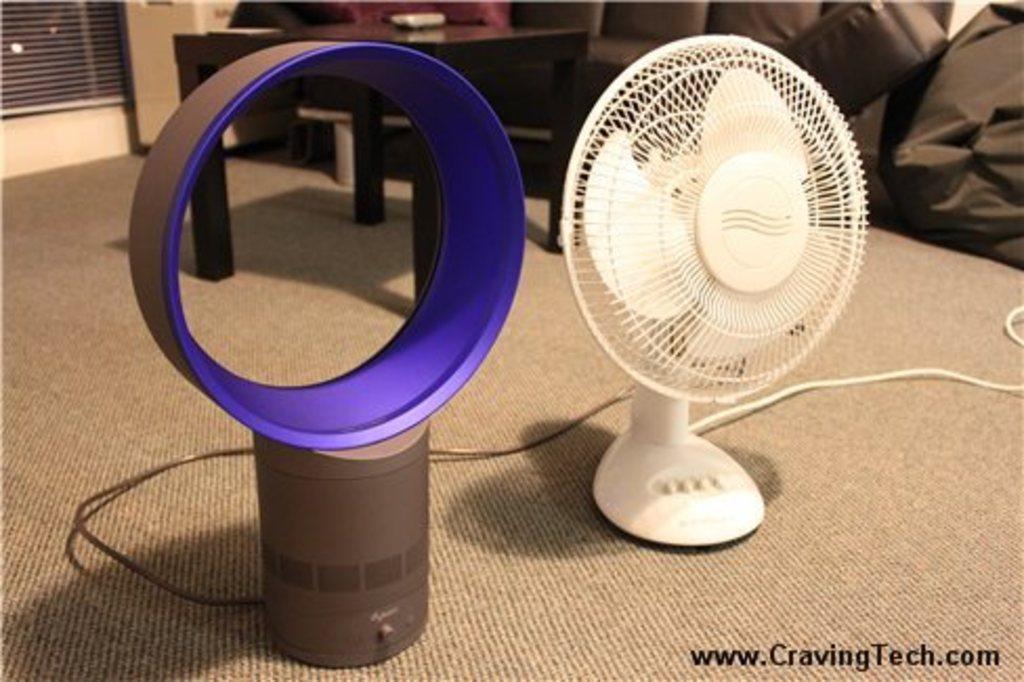How would you summarize this image in a sentence or two? In this image in the center there is a fan which is white in colour and there is a table which is black in colour and there are wires and on the right side there is an object which is black in colour. 